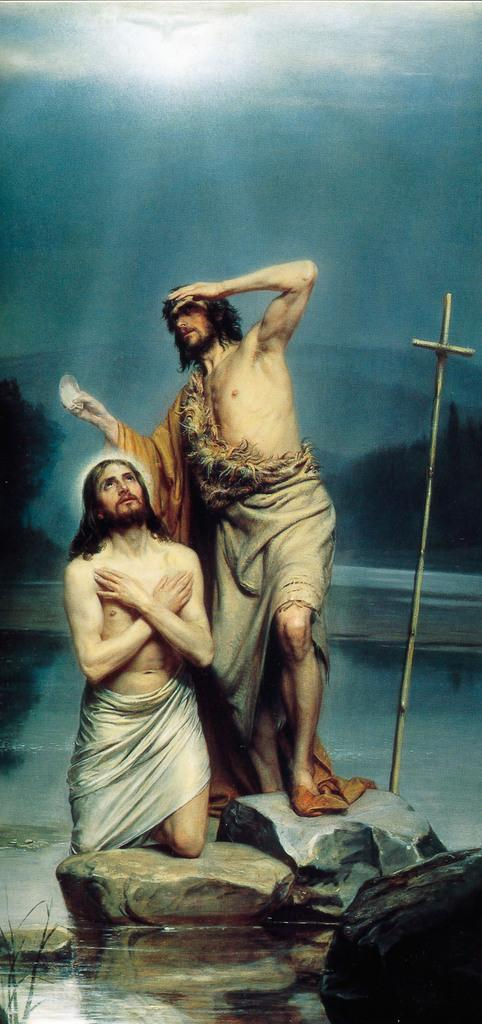How many people are present in the image? There are two people in the image. What type of natural elements can be seen in the image? There are rocks, water, sticks, and trees visible in the image. What is visible in the background of the image? The sky is visible in the background of the image. What type of car can be seen driving through the plants in the image? There is no car present in the image, and no plants are mentioned in the provided facts. 